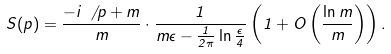Convert formula to latex. <formula><loc_0><loc_0><loc_500><loc_500>S ( p ) = \frac { - i \, \not \, p + m } { m } \cdot \frac { 1 } { m \epsilon - \frac { 1 } { 2 \pi } \ln \frac { \epsilon } { 4 } } \left ( 1 + O \left ( \frac { \ln m } { m } \right ) \right ) .</formula> 